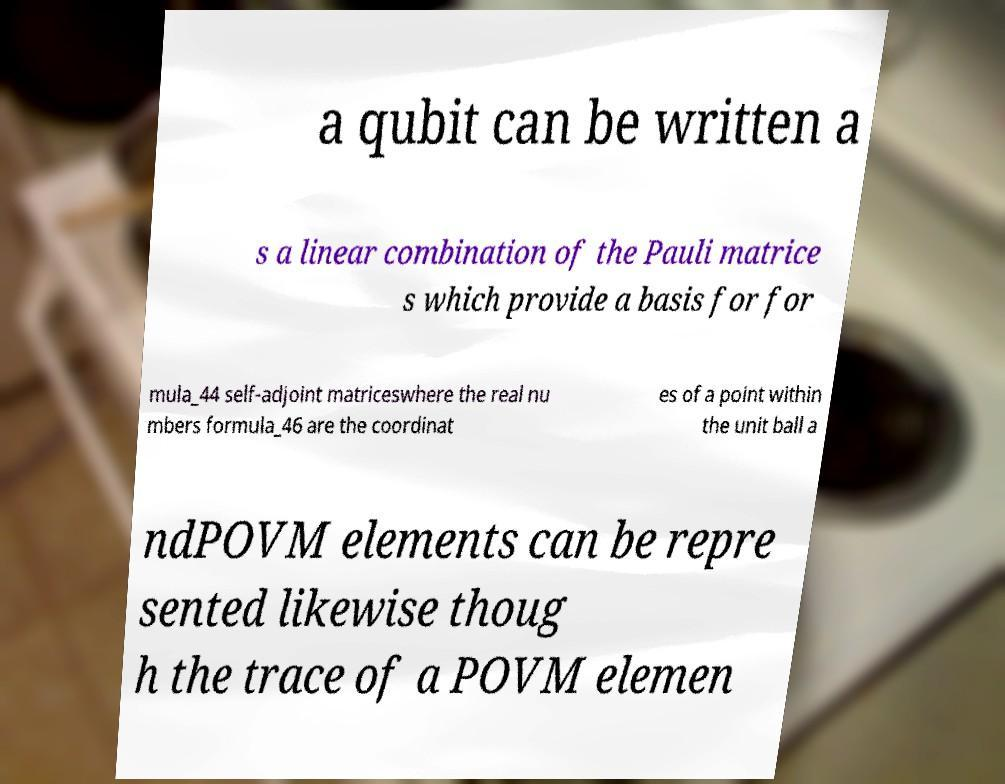Could you extract and type out the text from this image? a qubit can be written a s a linear combination of the Pauli matrice s which provide a basis for for mula_44 self-adjoint matriceswhere the real nu mbers formula_46 are the coordinat es of a point within the unit ball a ndPOVM elements can be repre sented likewise thoug h the trace of a POVM elemen 